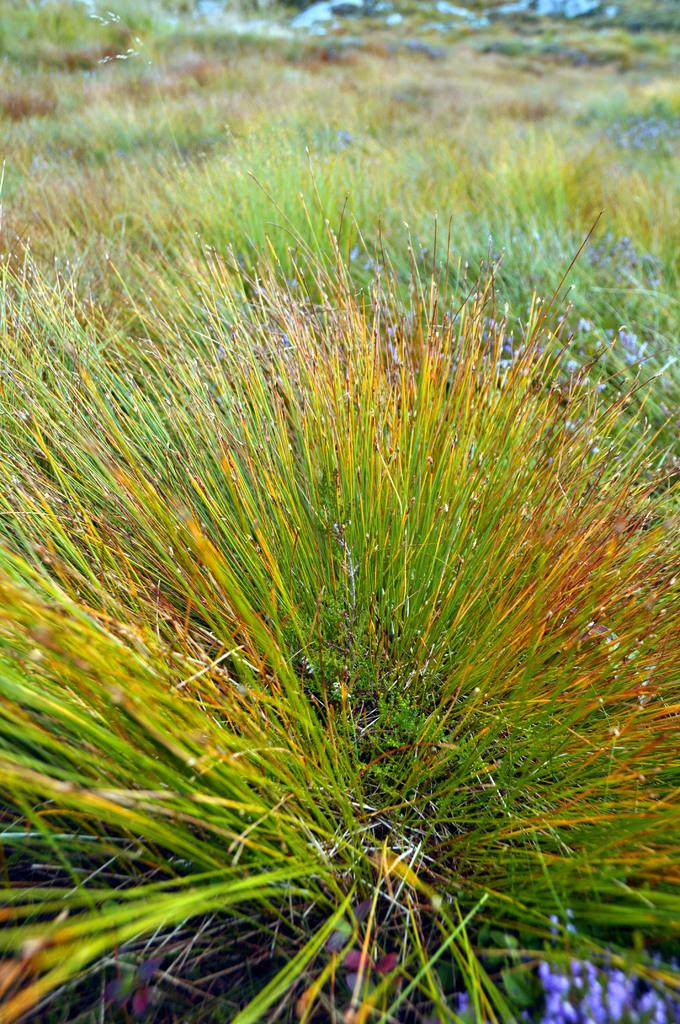What is the dominant color or theme in the image? The image is full of greenery. Can you identify any specific type of vegetation in the image? Yes, there is grass visible in the image. What type of record can be seen in the image? There is no record present in the image; it is full of greenery and grass. What is the texture of the ladybug in the image? There is no ladybug present in the image. 